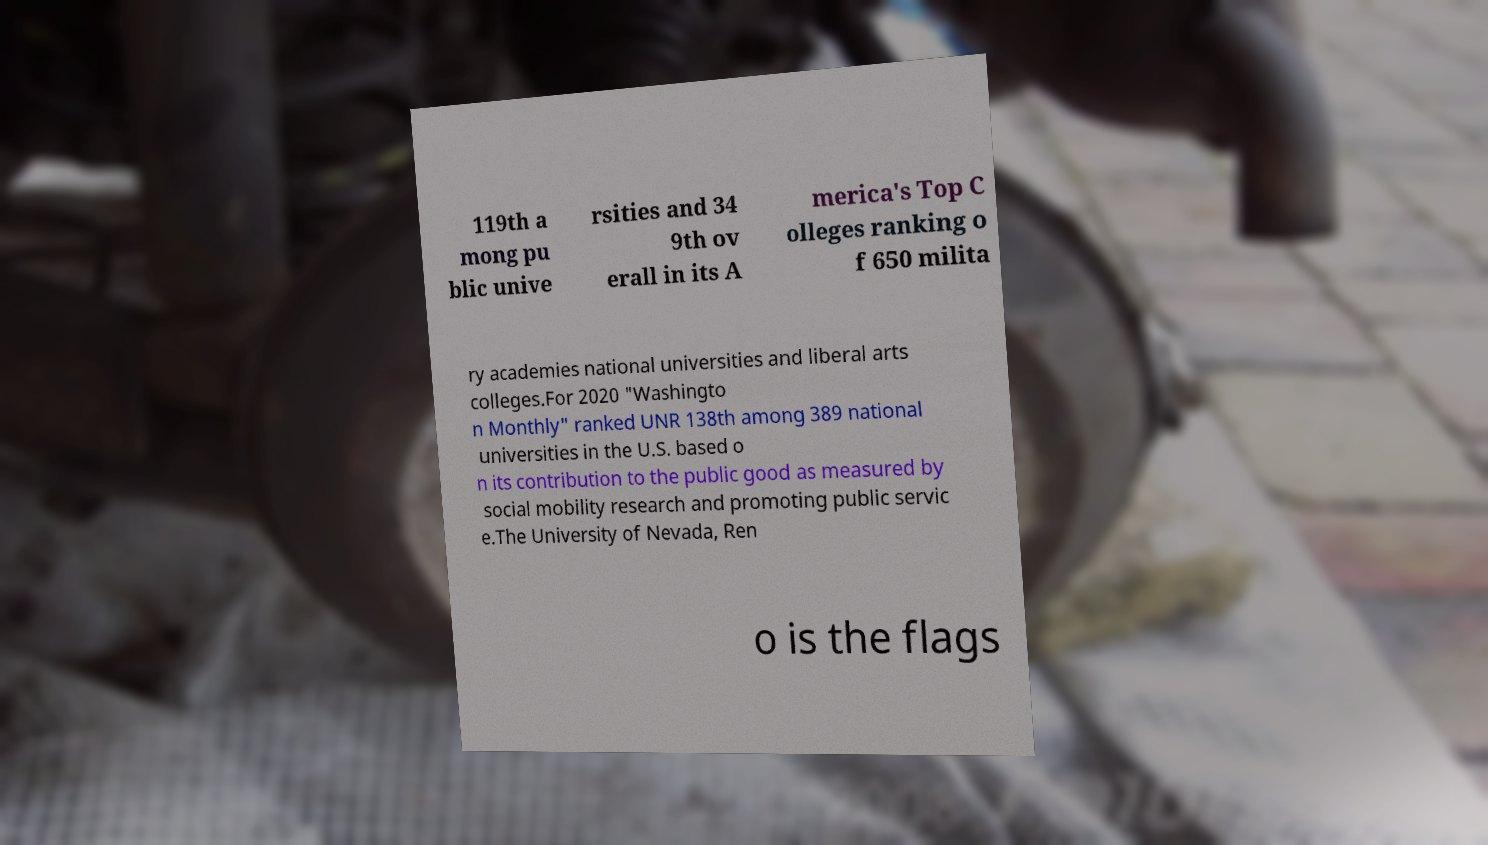Please identify and transcribe the text found in this image. 119th a mong pu blic unive rsities and 34 9th ov erall in its A merica's Top C olleges ranking o f 650 milita ry academies national universities and liberal arts colleges.For 2020 "Washingto n Monthly" ranked UNR 138th among 389 national universities in the U.S. based o n its contribution to the public good as measured by social mobility research and promoting public servic e.The University of Nevada, Ren o is the flags 